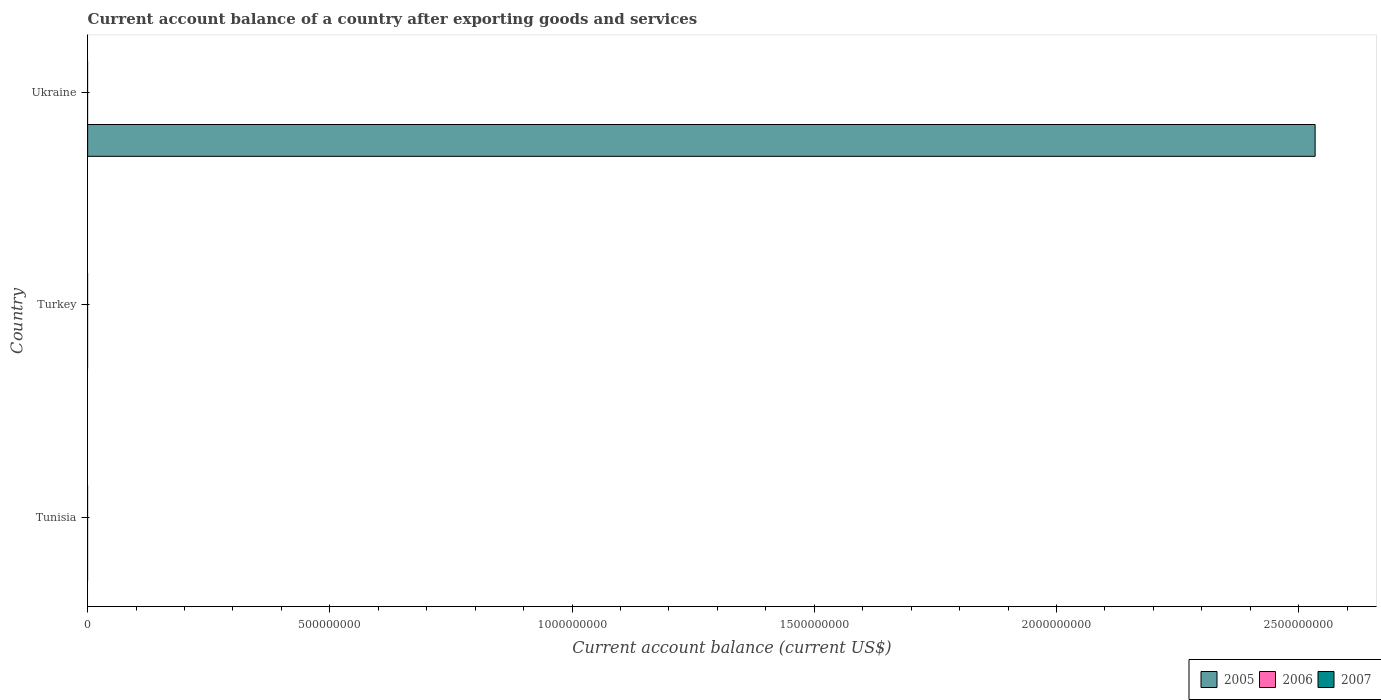How many different coloured bars are there?
Your answer should be compact. 1. What is the label of the 1st group of bars from the top?
Ensure brevity in your answer.  Ukraine. What is the account balance in 2005 in Ukraine?
Offer a terse response. 2.53e+09. Across all countries, what is the maximum account balance in 2005?
Keep it short and to the point. 2.53e+09. In which country was the account balance in 2005 maximum?
Provide a short and direct response. Ukraine. What is the total account balance in 2005 in the graph?
Offer a terse response. 2.53e+09. In how many countries, is the account balance in 2007 greater than 1600000000 US$?
Provide a succinct answer. 0. What is the difference between the highest and the lowest account balance in 2005?
Offer a terse response. 2.53e+09. In how many countries, is the account balance in 2006 greater than the average account balance in 2006 taken over all countries?
Offer a very short reply. 0. Is it the case that in every country, the sum of the account balance in 2006 and account balance in 2005 is greater than the account balance in 2007?
Offer a terse response. No. What is the difference between two consecutive major ticks on the X-axis?
Give a very brief answer. 5.00e+08. Are the values on the major ticks of X-axis written in scientific E-notation?
Offer a terse response. No. Does the graph contain any zero values?
Ensure brevity in your answer.  Yes. Does the graph contain grids?
Your answer should be compact. No. How many legend labels are there?
Offer a terse response. 3. What is the title of the graph?
Keep it short and to the point. Current account balance of a country after exporting goods and services. Does "1960" appear as one of the legend labels in the graph?
Your response must be concise. No. What is the label or title of the X-axis?
Ensure brevity in your answer.  Current account balance (current US$). What is the label or title of the Y-axis?
Offer a very short reply. Country. What is the Current account balance (current US$) of 2005 in Turkey?
Ensure brevity in your answer.  0. What is the Current account balance (current US$) of 2007 in Turkey?
Provide a succinct answer. 0. What is the Current account balance (current US$) of 2005 in Ukraine?
Your answer should be compact. 2.53e+09. What is the Current account balance (current US$) of 2006 in Ukraine?
Provide a succinct answer. 0. What is the Current account balance (current US$) of 2007 in Ukraine?
Keep it short and to the point. 0. Across all countries, what is the maximum Current account balance (current US$) of 2005?
Your answer should be very brief. 2.53e+09. What is the total Current account balance (current US$) of 2005 in the graph?
Your response must be concise. 2.53e+09. What is the total Current account balance (current US$) of 2006 in the graph?
Make the answer very short. 0. What is the average Current account balance (current US$) in 2005 per country?
Offer a terse response. 8.45e+08. What is the average Current account balance (current US$) of 2007 per country?
Ensure brevity in your answer.  0. What is the difference between the highest and the lowest Current account balance (current US$) in 2005?
Keep it short and to the point. 2.53e+09. 